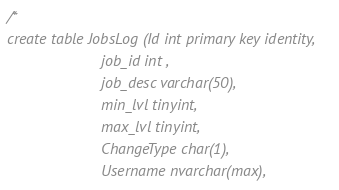Convert code to text. <code><loc_0><loc_0><loc_500><loc_500><_SQL_>/*
create table JobsLog (Id int primary key identity,
					  job_id int ,
					  job_desc varchar(50),
					  min_lvl tinyint,
					  max_lvl tinyint,
					  ChangeType char(1),
					  Username nvarchar(max),</code> 